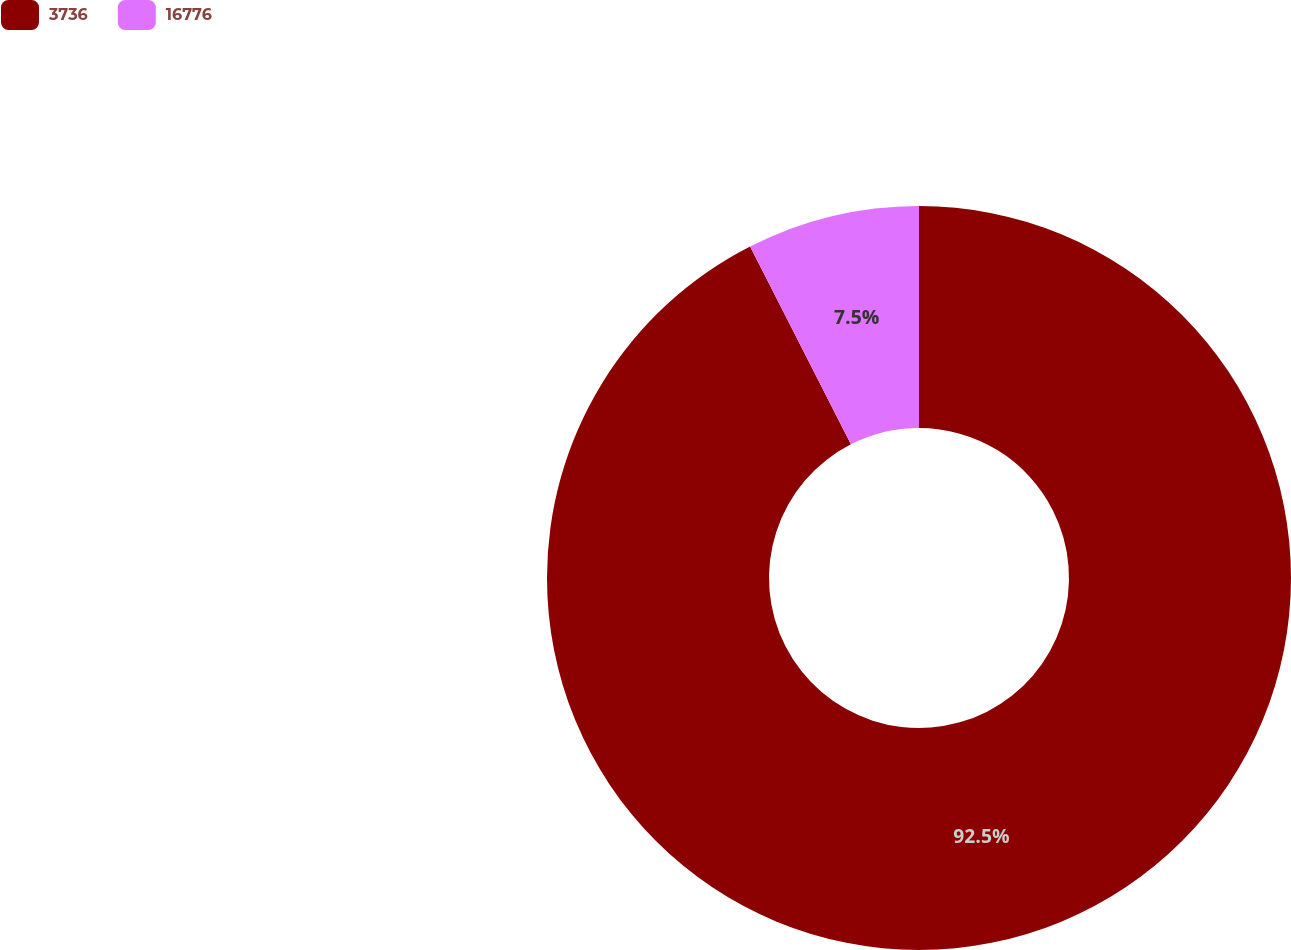<chart> <loc_0><loc_0><loc_500><loc_500><pie_chart><fcel>3736<fcel>16776<nl><fcel>92.5%<fcel>7.5%<nl></chart> 